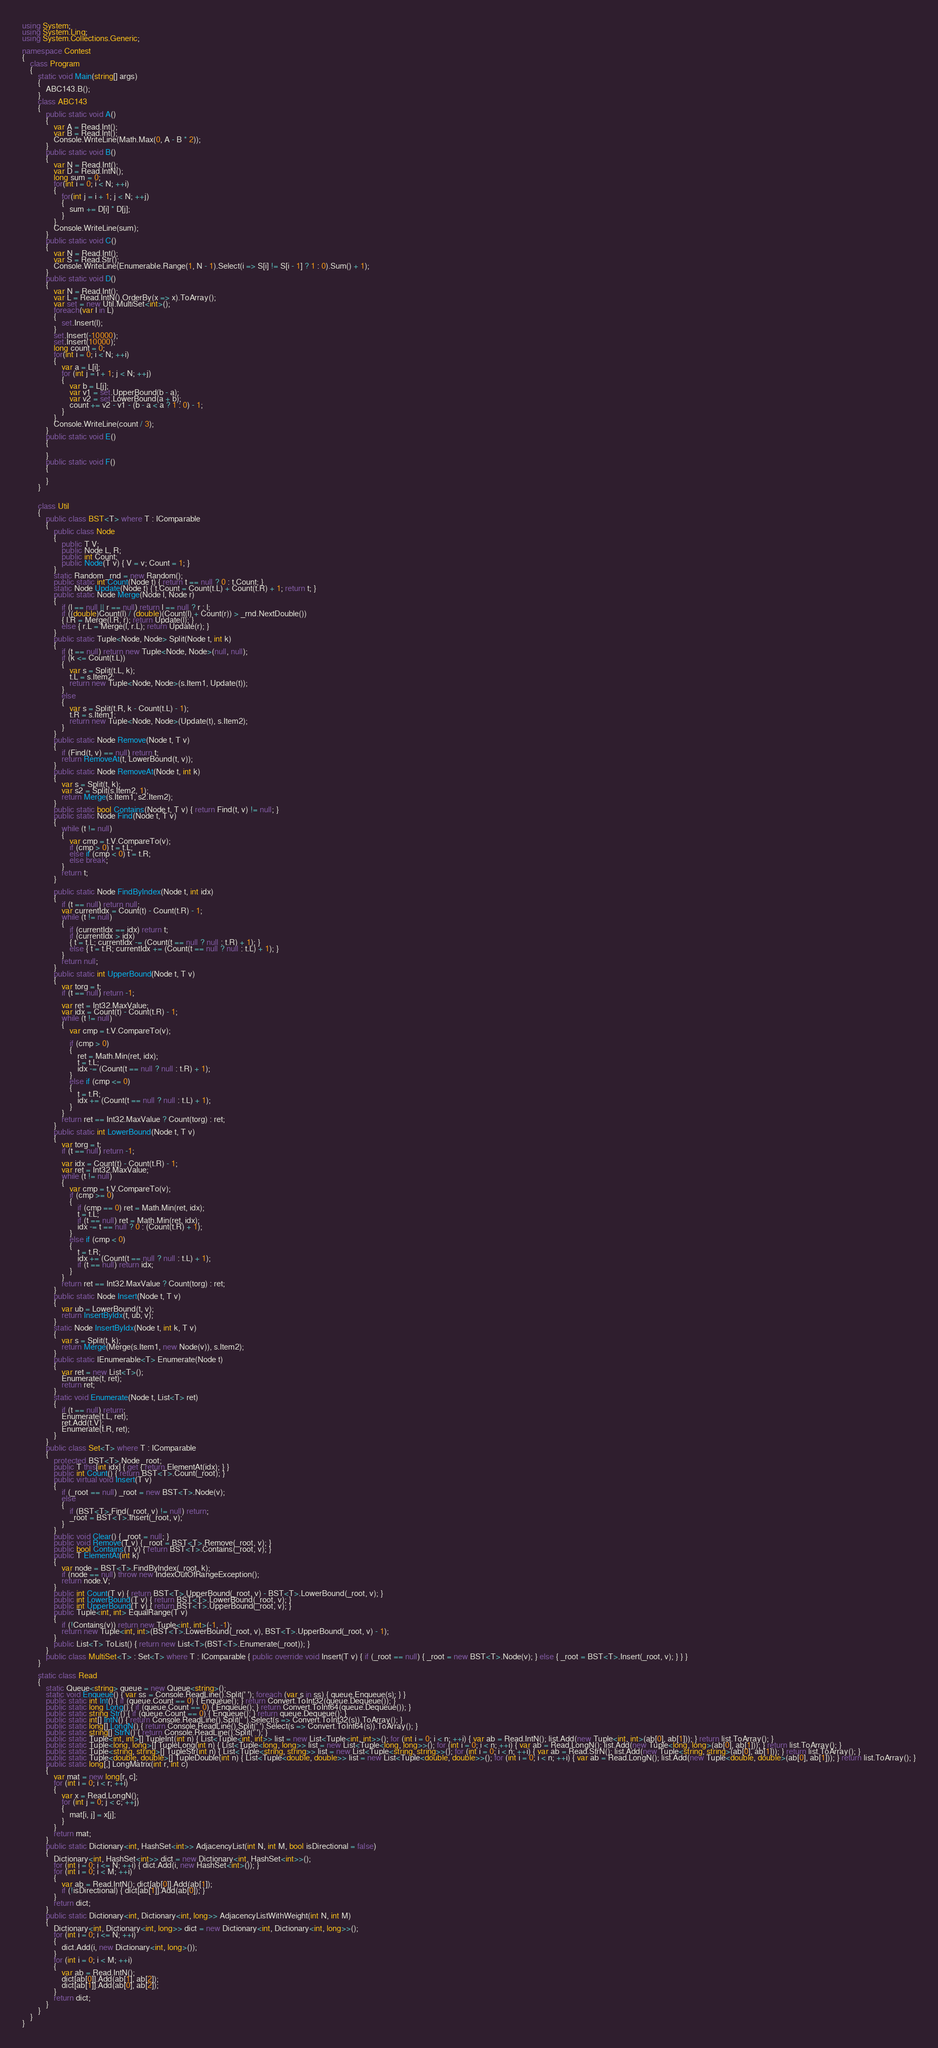<code> <loc_0><loc_0><loc_500><loc_500><_C#_>using System;
using System.Linq;
using System.Collections.Generic;

namespace Contest
{
    class Program
    {
        static void Main(string[] args)
        {
            ABC143.B();
        }
        class ABC143
        {
            public static void A()
            {
                var A = Read.Int();
                var B = Read.Int();
                Console.WriteLine(Math.Max(0, A - B * 2));
            }
            public static void B()
            {
                var N = Read.Int();
                var D = Read.IntN();
                long sum = 0;
                for(int i = 0; i < N; ++i)
                {
                    for(int j = i + 1; j < N; ++j)
                    {
                        sum += D[i] * D[j];
                    }
                }
                Console.WriteLine(sum);
            }
            public static void C()
            {
                var N = Read.Int();
                var S = Read.Str();
                Console.WriteLine(Enumerable.Range(1, N - 1).Select(i => S[i] != S[i - 1] ? 1 : 0).Sum() + 1);
            }
            public static void D()
            {
                var N = Read.Int();
                var L = Read.IntN().OrderBy(x => x).ToArray();
                var set = new Util.MultiSet<int>();
                foreach(var l in L)
                {
                    set.Insert(l);
                }
                set.Insert(-10000);
                set.Insert(10000);
                long count = 0;
                for(int i = 0; i < N; ++i)
                {
                    var a = L[i];
                    for (int j = i + 1; j < N; ++j)
                    {
                        var b = L[j];
                        var v1 = set.UpperBound(b - a);
                        var v2 = set.LowerBound(a + b);
                        count += v2 - v1 - (b - a < a ? 1 : 0) - 1;
                    }
                }
                Console.WriteLine(count / 3);
            }
            public static void E()
            {

            }
            public static void F()
            {

            }
        }


        class Util
        {
            public class BST<T> where T : IComparable
            {
                public class Node
                {
                    public T V;
                    public Node L, R;
                    public int Count;
                    public Node(T v) { V = v; Count = 1; }
                }
                static Random _rnd = new Random();
                public static int Count(Node t) { return t == null ? 0 : t.Count; }
                static Node Update(Node t) { t.Count = Count(t.L) + Count(t.R) + 1; return t; }
                public static Node Merge(Node l, Node r)
                {
                    if (l == null || r == null) return l == null ? r : l;
                    if ((double)Count(l) / (double)(Count(l) + Count(r)) > _rnd.NextDouble())
                    { l.R = Merge(l.R, r); return Update(l); }
                    else { r.L = Merge(l, r.L); return Update(r); }
                }
                public static Tuple<Node, Node> Split(Node t, int k)
                {
                    if (t == null) return new Tuple<Node, Node>(null, null);
                    if (k <= Count(t.L))
                    {
                        var s = Split(t.L, k);
                        t.L = s.Item2;
                        return new Tuple<Node, Node>(s.Item1, Update(t));
                    }
                    else
                    {
                        var s = Split(t.R, k - Count(t.L) - 1);
                        t.R = s.Item1;
                        return new Tuple<Node, Node>(Update(t), s.Item2);
                    }
                }
                public static Node Remove(Node t, T v)
                {
                    if (Find(t, v) == null) return t;
                    return RemoveAt(t, LowerBound(t, v));
                }
                public static Node RemoveAt(Node t, int k)
                {
                    var s = Split(t, k);
                    var s2 = Split(s.Item2, 1);
                    return Merge(s.Item1, s2.Item2);
                }
                public static bool Contains(Node t, T v) { return Find(t, v) != null; }
                public static Node Find(Node t, T v)
                {
                    while (t != null)
                    {
                        var cmp = t.V.CompareTo(v);
                        if (cmp > 0) t = t.L;
                        else if (cmp < 0) t = t.R;
                        else break;
                    }
                    return t;
                }

                public static Node FindByIndex(Node t, int idx)
                {
                    if (t == null) return null;
                    var currentIdx = Count(t) - Count(t.R) - 1;
                    while (t != null)
                    {
                        if (currentIdx == idx) return t;
                        if (currentIdx > idx)
                        { t = t.L; currentIdx -= (Count(t == null ? null : t.R) + 1); }
                        else { t = t.R; currentIdx += (Count(t == null ? null : t.L) + 1); }
                    }
                    return null;
                }
                public static int UpperBound(Node t, T v)
                {
                    var torg = t;
                    if (t == null) return -1;

                    var ret = Int32.MaxValue;
                    var idx = Count(t) - Count(t.R) - 1;
                    while (t != null)
                    {
                        var cmp = t.V.CompareTo(v);

                        if (cmp > 0)
                        {
                            ret = Math.Min(ret, idx);
                            t = t.L;
                            idx -= (Count(t == null ? null : t.R) + 1);
                        }
                        else if (cmp <= 0)
                        {
                            t = t.R;
                            idx += (Count(t == null ? null : t.L) + 1);
                        }
                    }
                    return ret == Int32.MaxValue ? Count(torg) : ret;
                }
                public static int LowerBound(Node t, T v)
                {
                    var torg = t;
                    if (t == null) return -1;

                    var idx = Count(t) - Count(t.R) - 1;
                    var ret = Int32.MaxValue;
                    while (t != null)
                    {
                        var cmp = t.V.CompareTo(v);
                        if (cmp >= 0)
                        {
                            if (cmp == 0) ret = Math.Min(ret, idx);
                            t = t.L;
                            if (t == null) ret = Math.Min(ret, idx);
                            idx -= t == null ? 0 : (Count(t.R) + 1);
                        }
                        else if (cmp < 0)
                        {
                            t = t.R;
                            idx += (Count(t == null ? null : t.L) + 1);
                            if (t == null) return idx;
                        }
                    }
                    return ret == Int32.MaxValue ? Count(torg) : ret;
                }
                public static Node Insert(Node t, T v)
                {
                    var ub = LowerBound(t, v);
                    return InsertByIdx(t, ub, v);
                }
                static Node InsertByIdx(Node t, int k, T v)
                {
                    var s = Split(t, k);
                    return Merge(Merge(s.Item1, new Node(v)), s.Item2);
                }
                public static IEnumerable<T> Enumerate(Node t)
                {
                    var ret = new List<T>();
                    Enumerate(t, ret);
                    return ret;
                }
                static void Enumerate(Node t, List<T> ret)
                {
                    if (t == null) return;
                    Enumerate(t.L, ret);
                    ret.Add(t.V);
                    Enumerate(t.R, ret);
                }
            }
            public class Set<T> where T : IComparable
            {
                protected BST<T>.Node _root;
                public T this[int idx] { get { return ElementAt(idx); } }
                public int Count() { return BST<T>.Count(_root); }
                public virtual void Insert(T v)
                {
                    if (_root == null) _root = new BST<T>.Node(v);
                    else
                    {
                        if (BST<T>.Find(_root, v) != null) return;
                        _root = BST<T>.Insert(_root, v);
                    }
                }
                public void Clear() { _root = null; }
                public void Remove(T v) { _root = BST<T>.Remove(_root, v); }
                public bool Contains(T v) { return BST<T>.Contains(_root, v); }
                public T ElementAt(int k)
                {
                    var node = BST<T>.FindByIndex(_root, k);
                    if (node == null) throw new IndexOutOfRangeException();
                    return node.V;
                }
                public int Count(T v) { return BST<T>.UpperBound(_root, v) - BST<T>.LowerBound(_root, v); }
                public int LowerBound(T v) { return BST<T>.LowerBound(_root, v); }
                public int UpperBound(T v) { return BST<T>.UpperBound(_root, v); }
                public Tuple<int, int> EqualRange(T v)
                {
                    if (!Contains(v)) return new Tuple<int, int>(-1, -1);
                    return new Tuple<int, int>(BST<T>.LowerBound(_root, v), BST<T>.UpperBound(_root, v) - 1);
                }
                public List<T> ToList() { return new List<T>(BST<T>.Enumerate(_root)); }
            }
            public class MultiSet<T> : Set<T> where T : IComparable { public override void Insert(T v) { if (_root == null) { _root = new BST<T>.Node(v); } else { _root = BST<T>.Insert(_root, v); } } }
        }

        static class Read
        {
            static Queue<string> queue = new Queue<string>();
            static void Enqueue() { var ss = Console.ReadLine().Split(' '); foreach (var s in ss) { queue.Enqueue(s); } }
            public static int Int() { if (queue.Count == 0) { Enqueue(); } return Convert.ToInt32(queue.Dequeue()); }
            public static long Long() { if (queue.Count == 0) { Enqueue(); } return Convert.ToInt64(queue.Dequeue()); }
            public static string Str() { if (queue.Count == 0) { Enqueue(); } return queue.Dequeue(); }
            public static int[] IntN() { return Console.ReadLine().Split(' ').Select(s => Convert.ToInt32(s)).ToArray(); }
            public static long[] LongN() { return Console.ReadLine().Split(' ').Select(s => Convert.ToInt64(s)).ToArray(); }
            public static string[] StrN() { return Console.ReadLine().Split(' '); }
            public static Tuple<int, int>[] TupleInt(int n) { List<Tuple<int, int>> list = new List<Tuple<int, int>>(); for (int i = 0; i < n; ++i) { var ab = Read.IntN(); list.Add(new Tuple<int, int>(ab[0], ab[1])); } return list.ToArray(); }
            public static Tuple<long, long>[] TupleLong(int n) { List<Tuple<long, long>> list = new List<Tuple<long, long>>(); for (int i = 0; i < n; ++i) { var ab = Read.LongN(); list.Add(new Tuple<long, long>(ab[0], ab[1])); } return list.ToArray(); }
            public static Tuple<string, string>[] TupleStr(int n) { List<Tuple<string, string>> list = new List<Tuple<string, string>>(); for (int i = 0; i < n; ++i) { var ab = Read.StrN(); list.Add(new Tuple<string, string>(ab[0], ab[1])); } return list.ToArray(); }
            public static Tuple<double, double>[] TupleDouble(int n) { List<Tuple<double, double>> list = new List<Tuple<double, double>>(); for (int i = 0; i < n; ++i) { var ab = Read.LongN(); list.Add(new Tuple<double, double>(ab[0], ab[1])); } return list.ToArray(); }
            public static long[,] LongMatrix(int r, int c)
            {
                var mat = new long[r, c];
                for (int i = 0; i < r; ++i)
                {
                    var x = Read.LongN();
                    for (int j = 0; j < c; ++j)
                    {
                        mat[i, j] = x[j];
                    }
                }
                return mat;
            }
            public static Dictionary<int, HashSet<int>> AdjacencyList(int N, int M, bool isDirectional = false)
            {
                Dictionary<int, HashSet<int>> dict = new Dictionary<int, HashSet<int>>();
                for (int i = 0; i <= N; ++i) { dict.Add(i, new HashSet<int>()); }
                for (int i = 0; i < M; ++i)
                {
                    var ab = Read.IntN(); dict[ab[0]].Add(ab[1]);
                    if (!isDirectional) { dict[ab[1]].Add(ab[0]); }
                }
                return dict;
            }
            public static Dictionary<int, Dictionary<int, long>> AdjacencyListWithWeight(int N, int M)
            {
                Dictionary<int, Dictionary<int, long>> dict = new Dictionary<int, Dictionary<int, long>>();
                for (int i = 0; i <= N; ++i)
                {
                    dict.Add(i, new Dictionary<int, long>());
                }
                for (int i = 0; i < M; ++i)
                {
                    var ab = Read.IntN();
                    dict[ab[0]].Add(ab[1], ab[2]);
                    dict[ab[1]].Add(ab[0], ab[2]);
                }
                return dict;
            }
        }
    }
}
</code> 